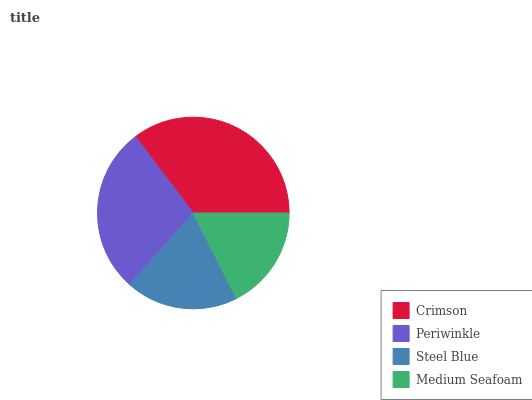Is Medium Seafoam the minimum?
Answer yes or no. Yes. Is Crimson the maximum?
Answer yes or no. Yes. Is Periwinkle the minimum?
Answer yes or no. No. Is Periwinkle the maximum?
Answer yes or no. No. Is Crimson greater than Periwinkle?
Answer yes or no. Yes. Is Periwinkle less than Crimson?
Answer yes or no. Yes. Is Periwinkle greater than Crimson?
Answer yes or no. No. Is Crimson less than Periwinkle?
Answer yes or no. No. Is Periwinkle the high median?
Answer yes or no. Yes. Is Steel Blue the low median?
Answer yes or no. Yes. Is Medium Seafoam the high median?
Answer yes or no. No. Is Periwinkle the low median?
Answer yes or no. No. 